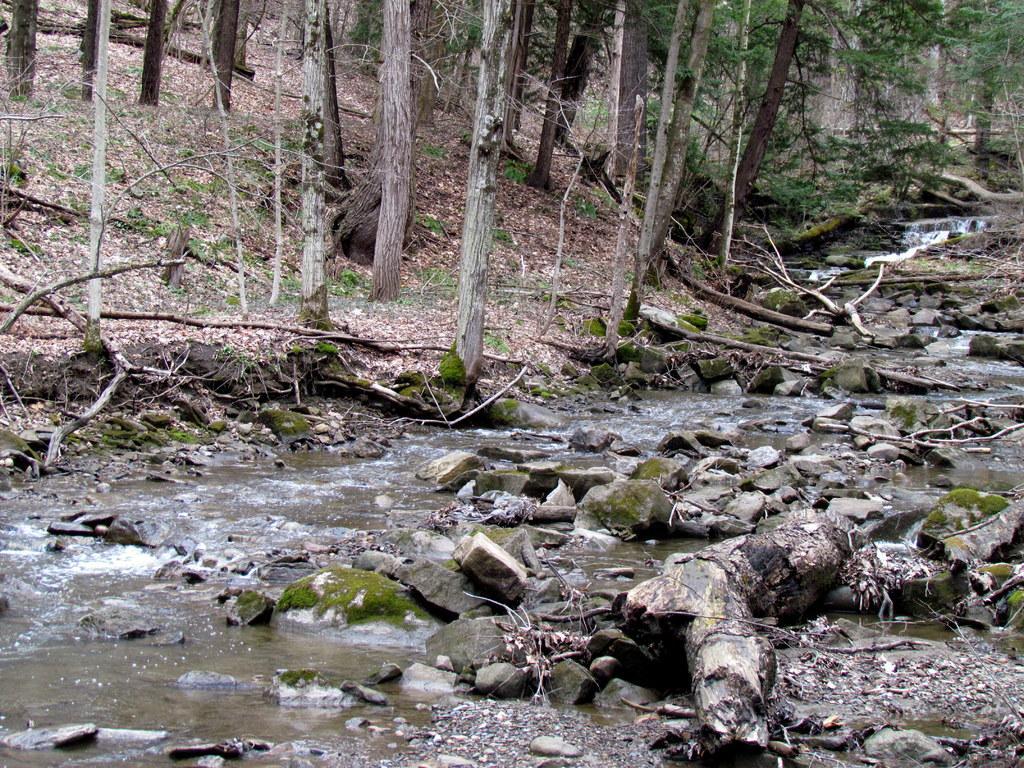How would you summarize this image in a sentence or two? Here in this picture we can see water flowing on the ground over a place and we can also see some stones and branches and logs of a tree present and we can see plants and trees present on the ground and we can see dry leaves present on the ground. 